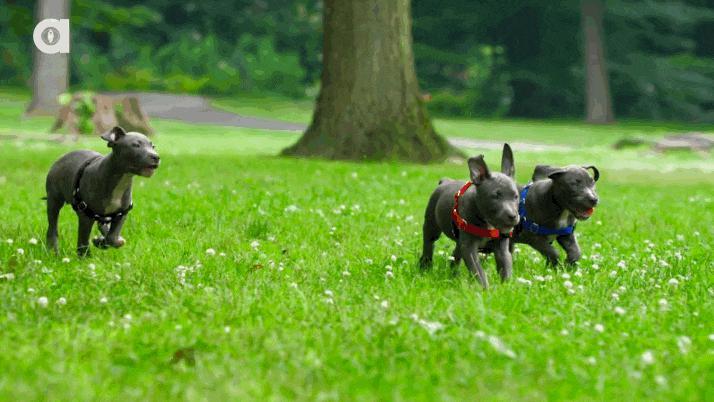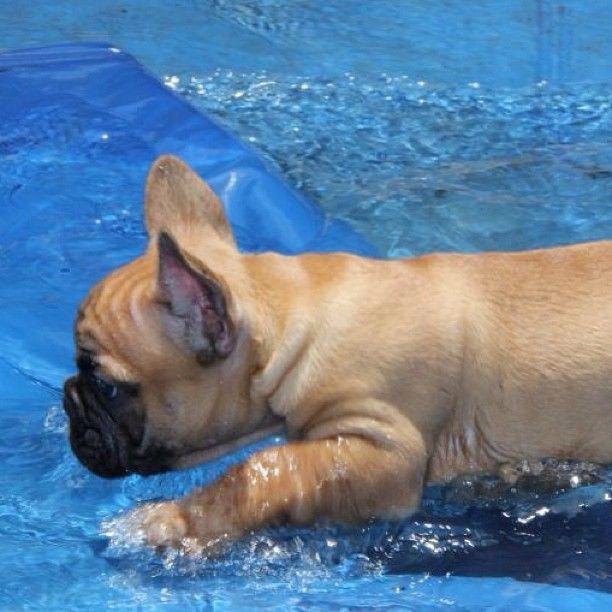The first image is the image on the left, the second image is the image on the right. Analyze the images presented: Is the assertion "there are dogs floating in the pool on inflatable intertubes" valid? Answer yes or no. No. 